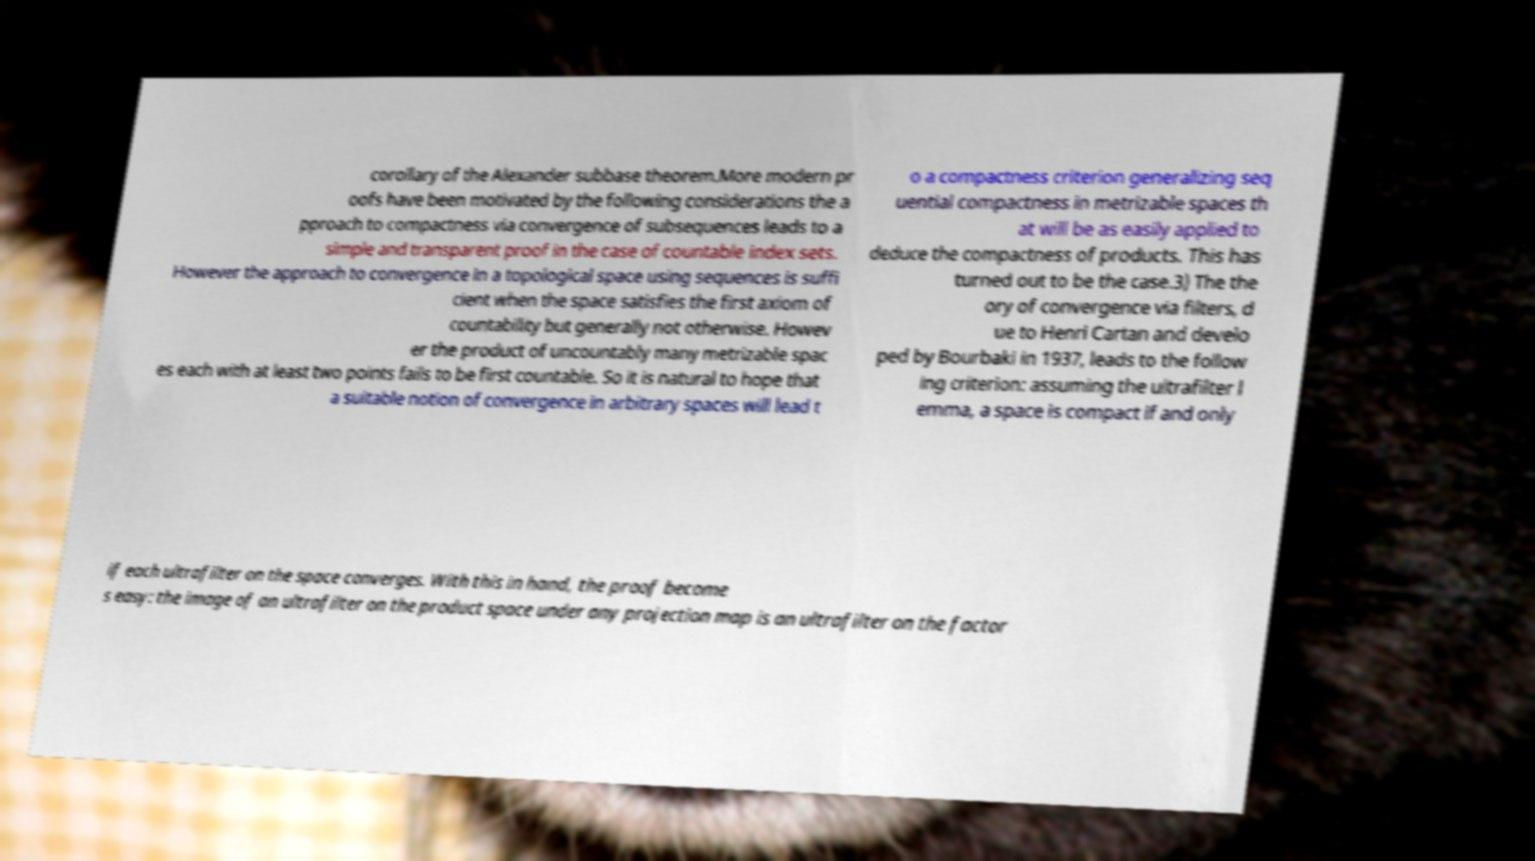Can you read and provide the text displayed in the image?This photo seems to have some interesting text. Can you extract and type it out for me? corollary of the Alexander subbase theorem.More modern pr oofs have been motivated by the following considerations the a pproach to compactness via convergence of subsequences leads to a simple and transparent proof in the case of countable index sets. However the approach to convergence in a topological space using sequences is suffi cient when the space satisfies the first axiom of countability but generally not otherwise. Howev er the product of uncountably many metrizable spac es each with at least two points fails to be first countable. So it is natural to hope that a suitable notion of convergence in arbitrary spaces will lead t o a compactness criterion generalizing seq uential compactness in metrizable spaces th at will be as easily applied to deduce the compactness of products. This has turned out to be the case.3) The the ory of convergence via filters, d ue to Henri Cartan and develo ped by Bourbaki in 1937, leads to the follow ing criterion: assuming the ultrafilter l emma, a space is compact if and only if each ultrafilter on the space converges. With this in hand, the proof become s easy: the image of an ultrafilter on the product space under any projection map is an ultrafilter on the factor 